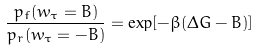Convert formula to latex. <formula><loc_0><loc_0><loc_500><loc_500>\frac { p _ { f } ( w _ { \tau } = B ) } { p _ { r } ( w _ { \tau } = - B ) } = \exp [ - \beta ( \Delta G - B ) ]</formula> 